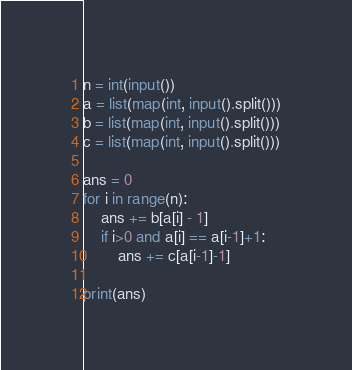Convert code to text. <code><loc_0><loc_0><loc_500><loc_500><_Python_>n = int(input())
a = list(map(int, input().split()))
b = list(map(int, input().split()))
c = list(map(int, input().split()))

ans = 0
for i in range(n):
    ans += b[a[i] - 1]
    if i>0 and a[i] == a[i-1]+1:
        ans += c[a[i-1]-1]
        
print(ans)</code> 